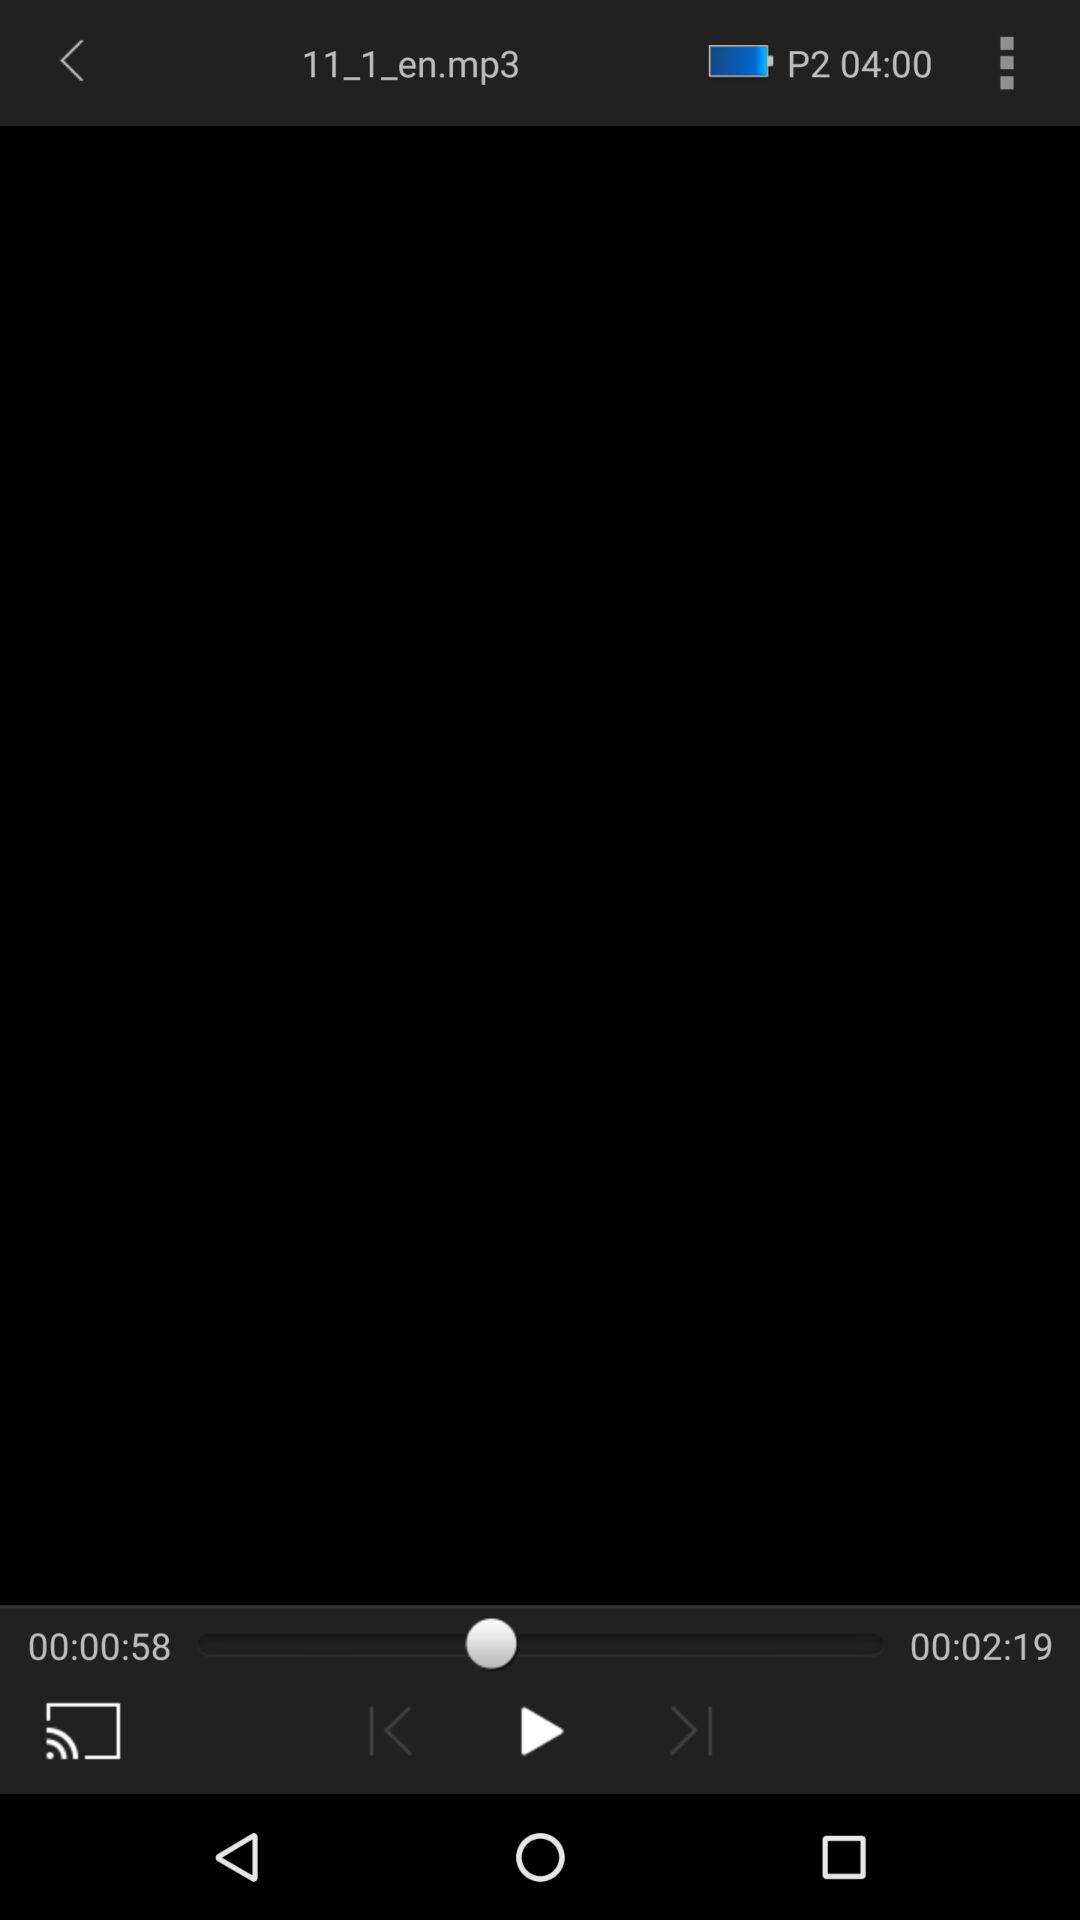What is the elapsed time of the audio track? The elapsed time of the audio track is 58 seconds. 